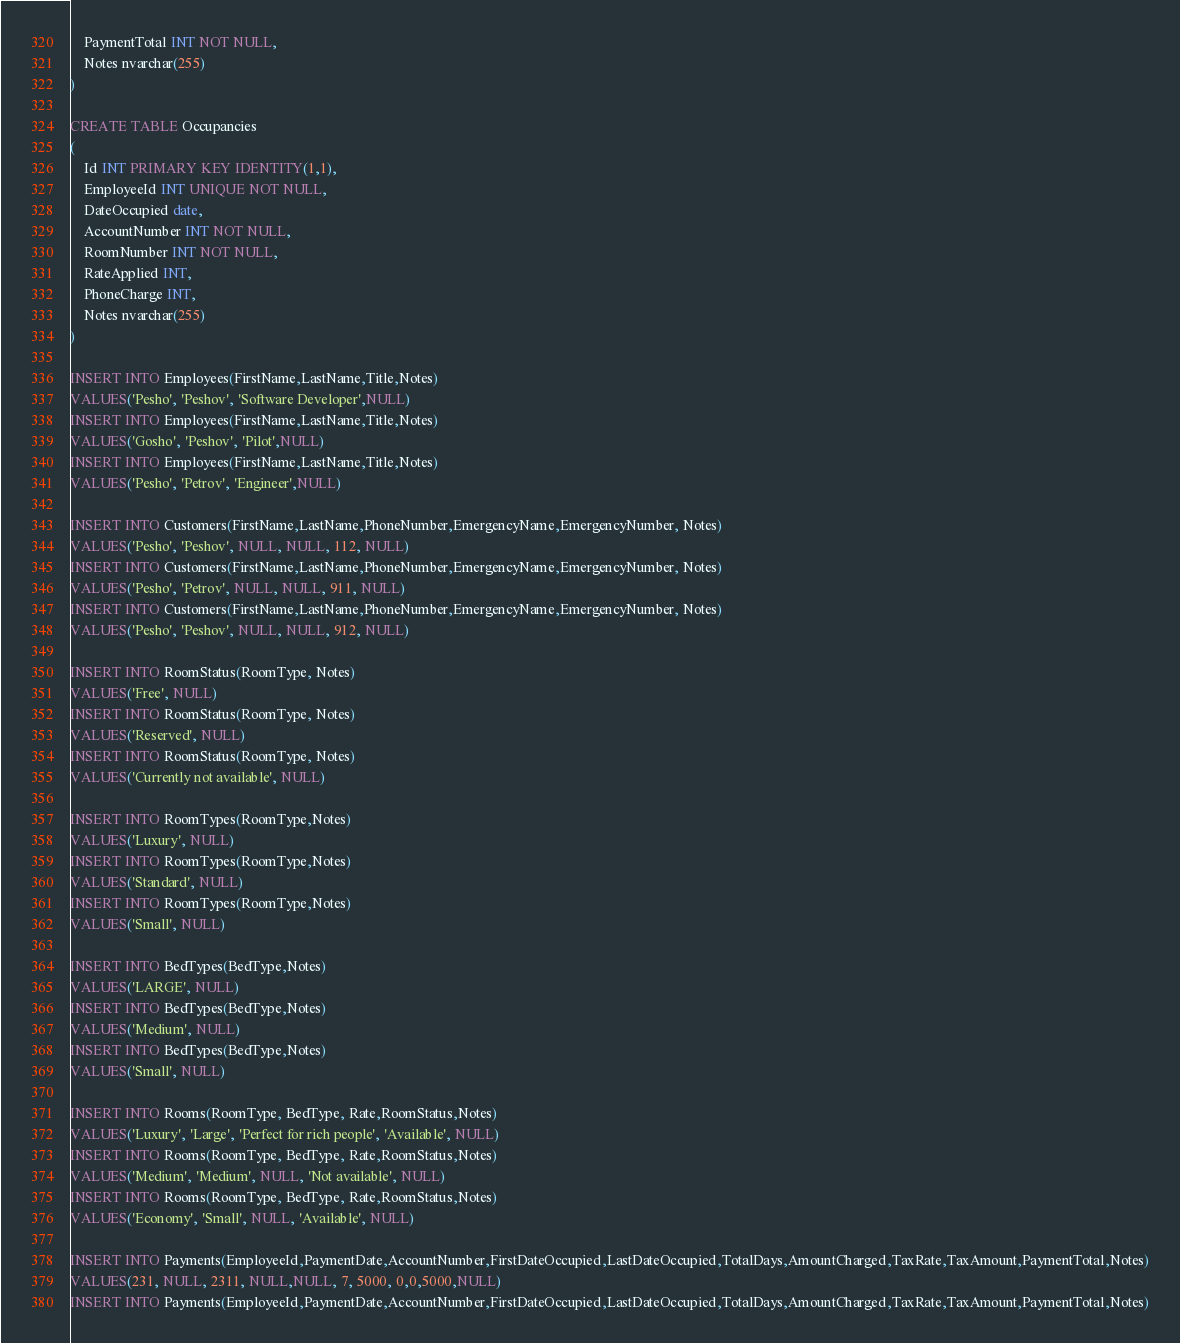Convert code to text. <code><loc_0><loc_0><loc_500><loc_500><_SQL_>	PaymentTotal INT NOT NULL,
	Notes nvarchar(255)
)

CREATE TABLE Occupancies
(
	Id INT PRIMARY KEY IDENTITY(1,1),
	EmployeeId INT UNIQUE NOT NULL,
	DateOccupied date,
	AccountNumber INT NOT NULL,
	RoomNumber INT NOT NULL,
	RateApplied INT,
	PhoneCharge INT,
	Notes nvarchar(255)
)

INSERT INTO Employees(FirstName,LastName,Title,Notes)
VALUES('Pesho', 'Peshov', 'Software Developer',NULL)
INSERT INTO Employees(FirstName,LastName,Title,Notes)
VALUES('Gosho', 'Peshov', 'Pilot',NULL)
INSERT INTO Employees(FirstName,LastName,Title,Notes)
VALUES('Pesho', 'Petrov', 'Engineer',NULL)

INSERT INTO Customers(FirstName,LastName,PhoneNumber,EmergencyName,EmergencyNumber, Notes)
VALUES('Pesho', 'Peshov', NULL, NULL, 112, NULL)
INSERT INTO Customers(FirstName,LastName,PhoneNumber,EmergencyName,EmergencyNumber, Notes)
VALUES('Pesho', 'Petrov', NULL, NULL, 911, NULL)
INSERT INTO Customers(FirstName,LastName,PhoneNumber,EmergencyName,EmergencyNumber, Notes)
VALUES('Pesho', 'Peshov', NULL, NULL, 912, NULL)

INSERT INTO RoomStatus(RoomType, Notes)
VALUES('Free', NULL)
INSERT INTO RoomStatus(RoomType, Notes)
VALUES('Reserved', NULL)
INSERT INTO RoomStatus(RoomType, Notes)
VALUES('Currently not available', NULL)

INSERT INTO RoomTypes(RoomType,Notes)
VALUES('Luxury', NULL)
INSERT INTO RoomTypes(RoomType,Notes)
VALUES('Standard', NULL)
INSERT INTO RoomTypes(RoomType,Notes)
VALUES('Small', NULL)

INSERT INTO BedTypes(BedType,Notes)
VALUES('LARGE', NULL)
INSERT INTO BedTypes(BedType,Notes)
VALUES('Medium', NULL)
INSERT INTO BedTypes(BedType,Notes)
VALUES('Small', NULL)

INSERT INTO Rooms(RoomType, BedType, Rate,RoomStatus,Notes)
VALUES('Luxury', 'Large', 'Perfect for rich people', 'Available', NULL)
INSERT INTO Rooms(RoomType, BedType, Rate,RoomStatus,Notes)
VALUES('Medium', 'Medium', NULL, 'Not available', NULL)
INSERT INTO Rooms(RoomType, BedType, Rate,RoomStatus,Notes)
VALUES('Economy', 'Small', NULL, 'Available', NULL)

INSERT INTO Payments(EmployeeId,PaymentDate,AccountNumber,FirstDateOccupied,LastDateOccupied,TotalDays,AmountCharged,TaxRate,TaxAmount,PaymentTotal,Notes)
VALUES(231, NULL, 2311, NULL,NULL, 7, 5000, 0,0,5000,NULL)
INSERT INTO Payments(EmployeeId,PaymentDate,AccountNumber,FirstDateOccupied,LastDateOccupied,TotalDays,AmountCharged,TaxRate,TaxAmount,PaymentTotal,Notes)</code> 